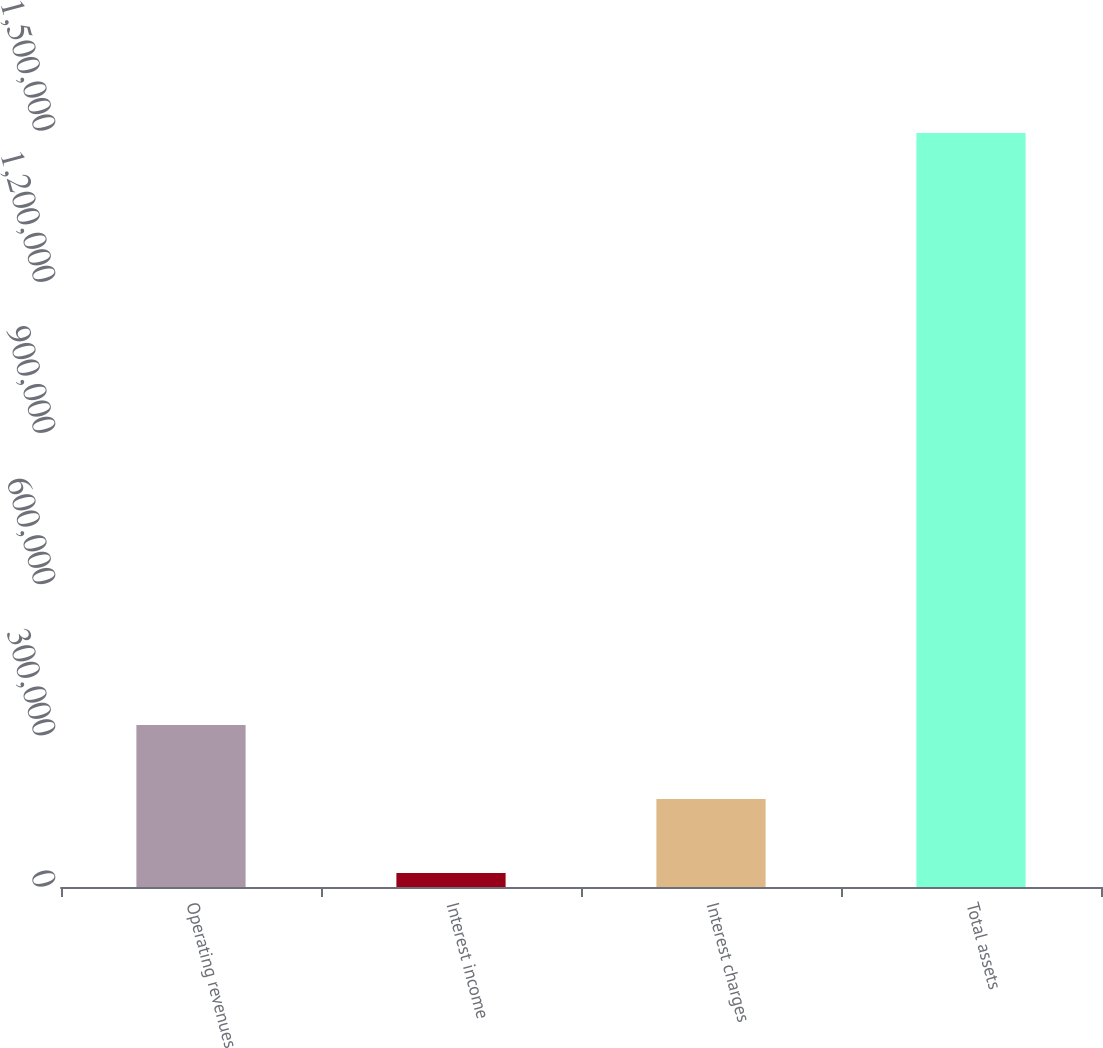Convert chart to OTSL. <chart><loc_0><loc_0><loc_500><loc_500><bar_chart><fcel>Operating revenues<fcel>Interest income<fcel>Interest charges<fcel>Total assets<nl><fcel>321241<fcel>27575<fcel>174408<fcel>1.4959e+06<nl></chart> 